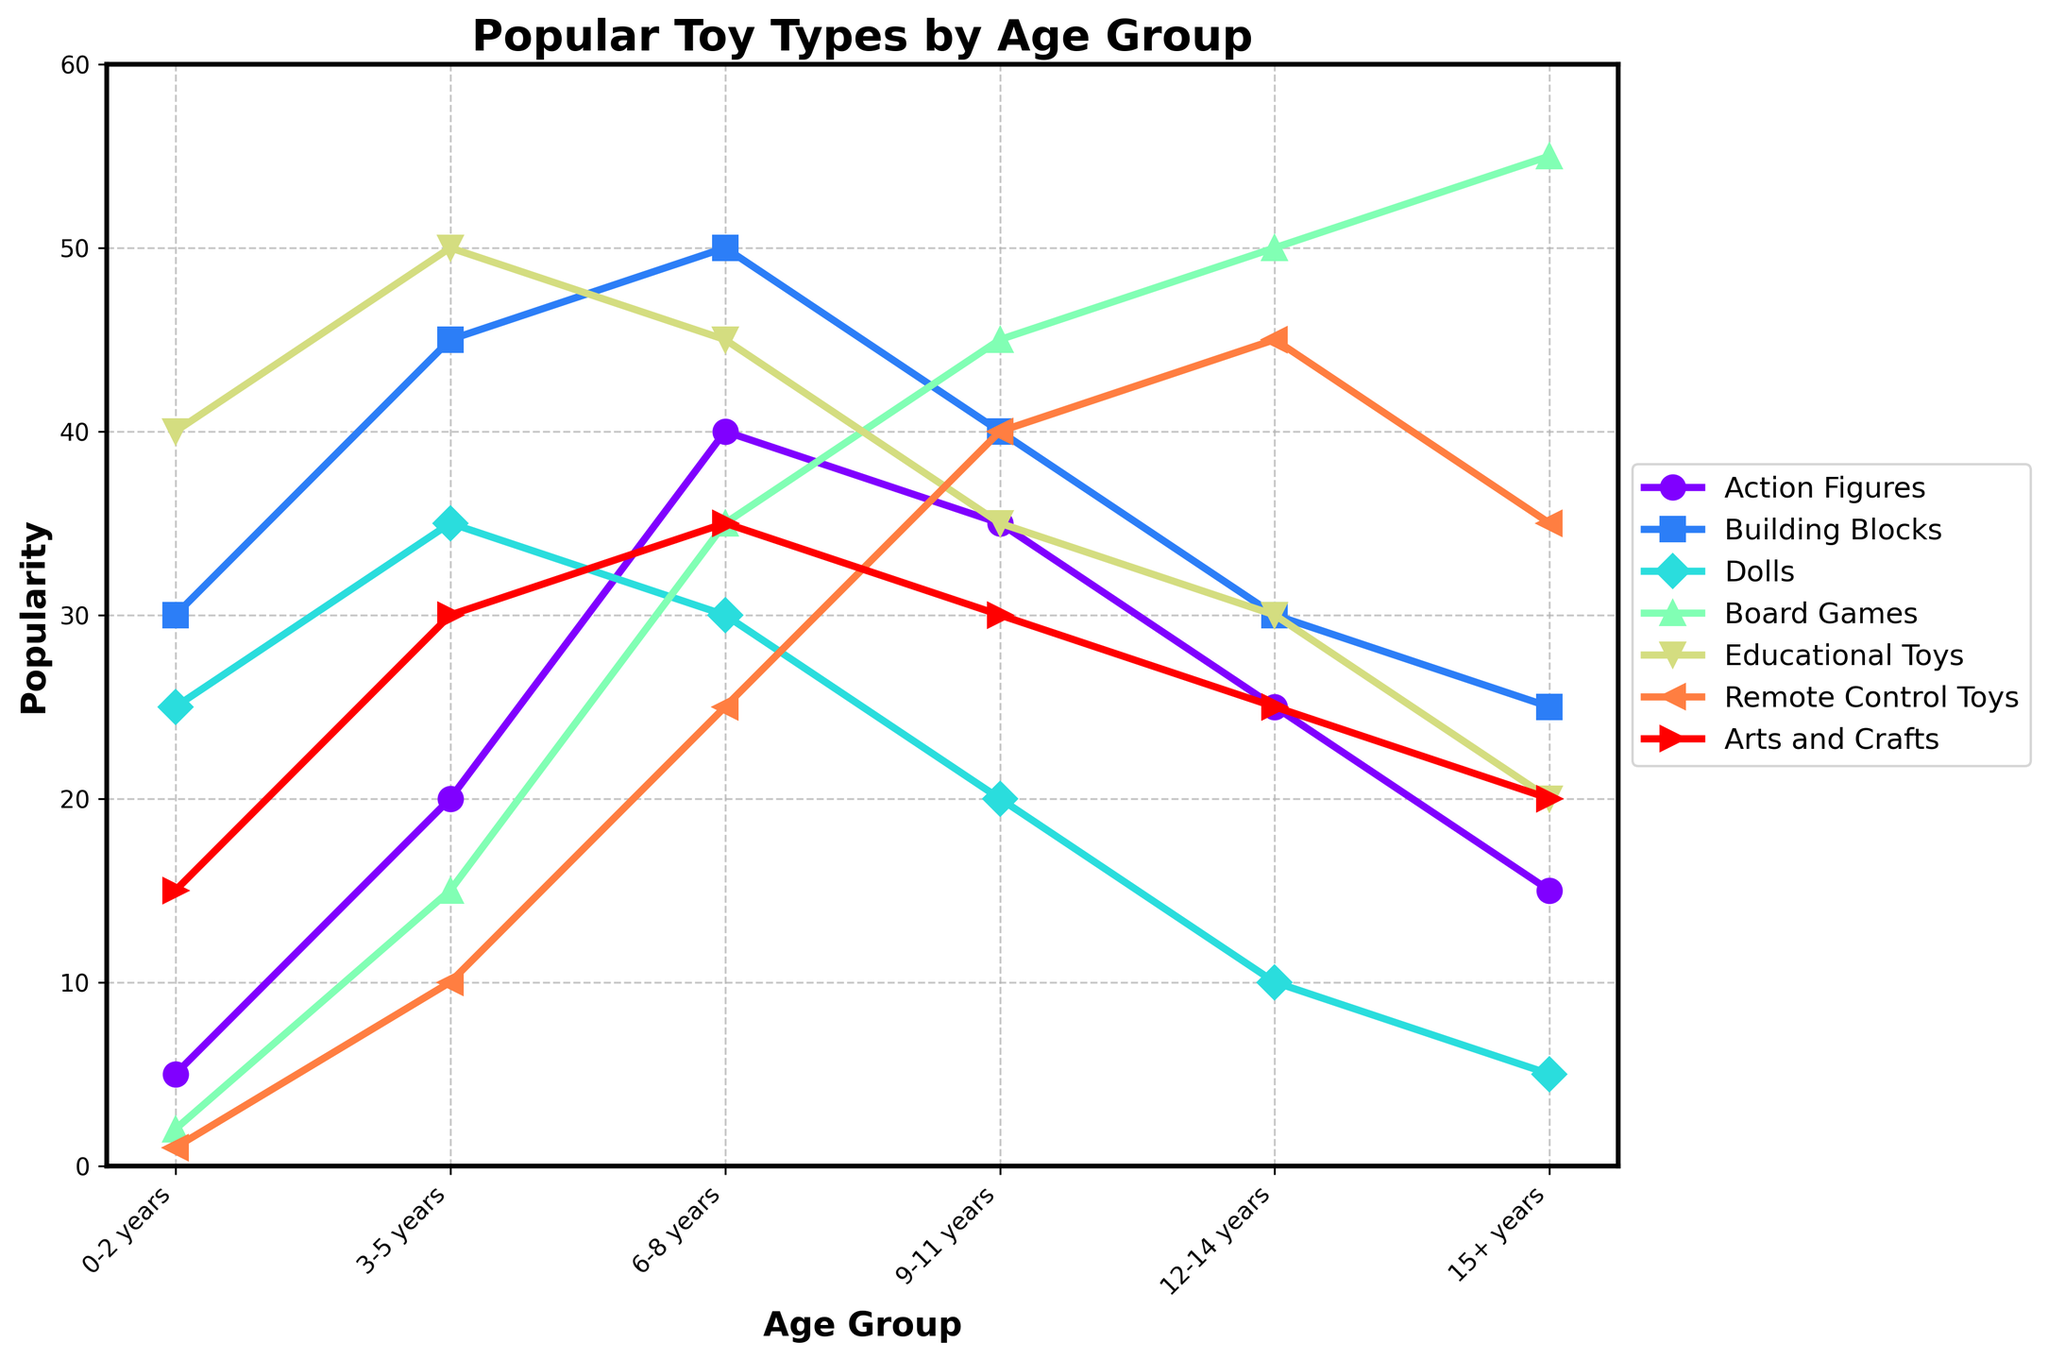Which age group shows the highest popularity for Building Blocks? Look at the Building Blocks line and find the age group with the highest point on the y-axis.
Answer: 6-8 years How much more popular are Dolls in the 6-8 years age group compared to the 9-11 years age group? The Dolls popularity for 6-8 years is 30, and for 9-11 years it's 20. Subtract the smaller value from the larger value: 30 - 20.
Answer: 10 Which toy type sees the most consistent decline in popularity as age increases? Track each toy type's line across different age groups and identify the one showing a consistent downward trend from left to right.
Answer: Dolls What is the average popularity of Board Games for age groups 6-8 years and 15+ years? Sum the popularity figures for Board Games in the 6-8 and 15+ age groups: 35 + 55, then divide by 2.
Answer: 45 Which toy type peaks in popularity for the 15+ age group? Locate the 15+ age group on the x-axis and see which toy type line reaches its highest point at that age.
Answer: Board Games How does the popularity of Action Figures in the 0-2 years age group compare with its popularity in the 12-14 years age group? The popularity for 0-2 years age group is 5 and for 12-14 years it's 25. Compare these two numbers.
Answer: 12-14 years is higher What color is the line representing the popularity of Remote Control Toys? Visual inspection of the line representing Remote Control Toys to determine its color.
Answer: Purple (assuming based on typical rainbow mapping; please verify on the chart) Which toy types have their peak popularity in the 9-11 years age group? Check all toy type lines and identify those reaching their highest point at the 9-11 years label on the x-axis.
Answer: Board Games, Remote Control Toys What is the total popularity of Educational Toys across all age groups? Sum the popularity figures for Educational Toys across all listed age groups: 40 + 50 + 45 + 35 + 30 + 20.
Answer: 220 Which age group shows the greatest diversity in toy preferences, defined by the largest range between the highest and lowest popularities for different toy types? For each age group, calculate the range (difference between the highest and lowest popularity values). Identify the age group with the largest range.
Answer: 3-5 years 